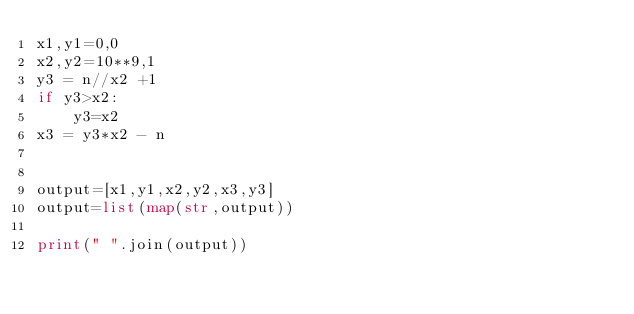<code> <loc_0><loc_0><loc_500><loc_500><_Python_>x1,y1=0,0
x2,y2=10**9,1
y3 = n//x2 +1
if y3>x2:
    y3=x2
x3 = y3*x2 - n


output=[x1,y1,x2,y2,x3,y3]
output=list(map(str,output))
    
print(" ".join(output))</code> 